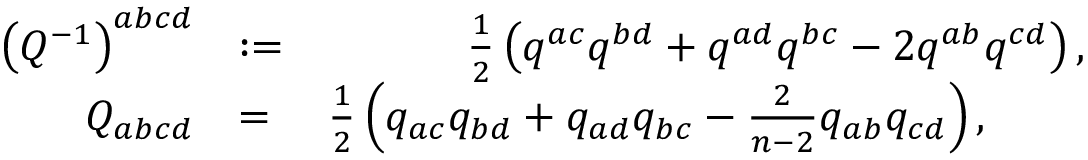<formula> <loc_0><loc_0><loc_500><loc_500>\begin{array} { r l r } { \left ( Q ^ { - 1 } \right ) ^ { a b c d } } & { \colon = } & { \frac { 1 } { 2 } \left ( q ^ { a c } q ^ { b d } + q ^ { a d } q ^ { b c } - 2 q ^ { a b } q ^ { c d } \right ) , } \\ { Q _ { a b c d } } & { = } & { \frac { 1 } { 2 } \left ( q _ { a c } q _ { b d } + q _ { a d } q _ { b c } - \frac { 2 } { n - 2 } q _ { a b } q _ { c d } \right ) , \quad \, } \end{array}</formula> 